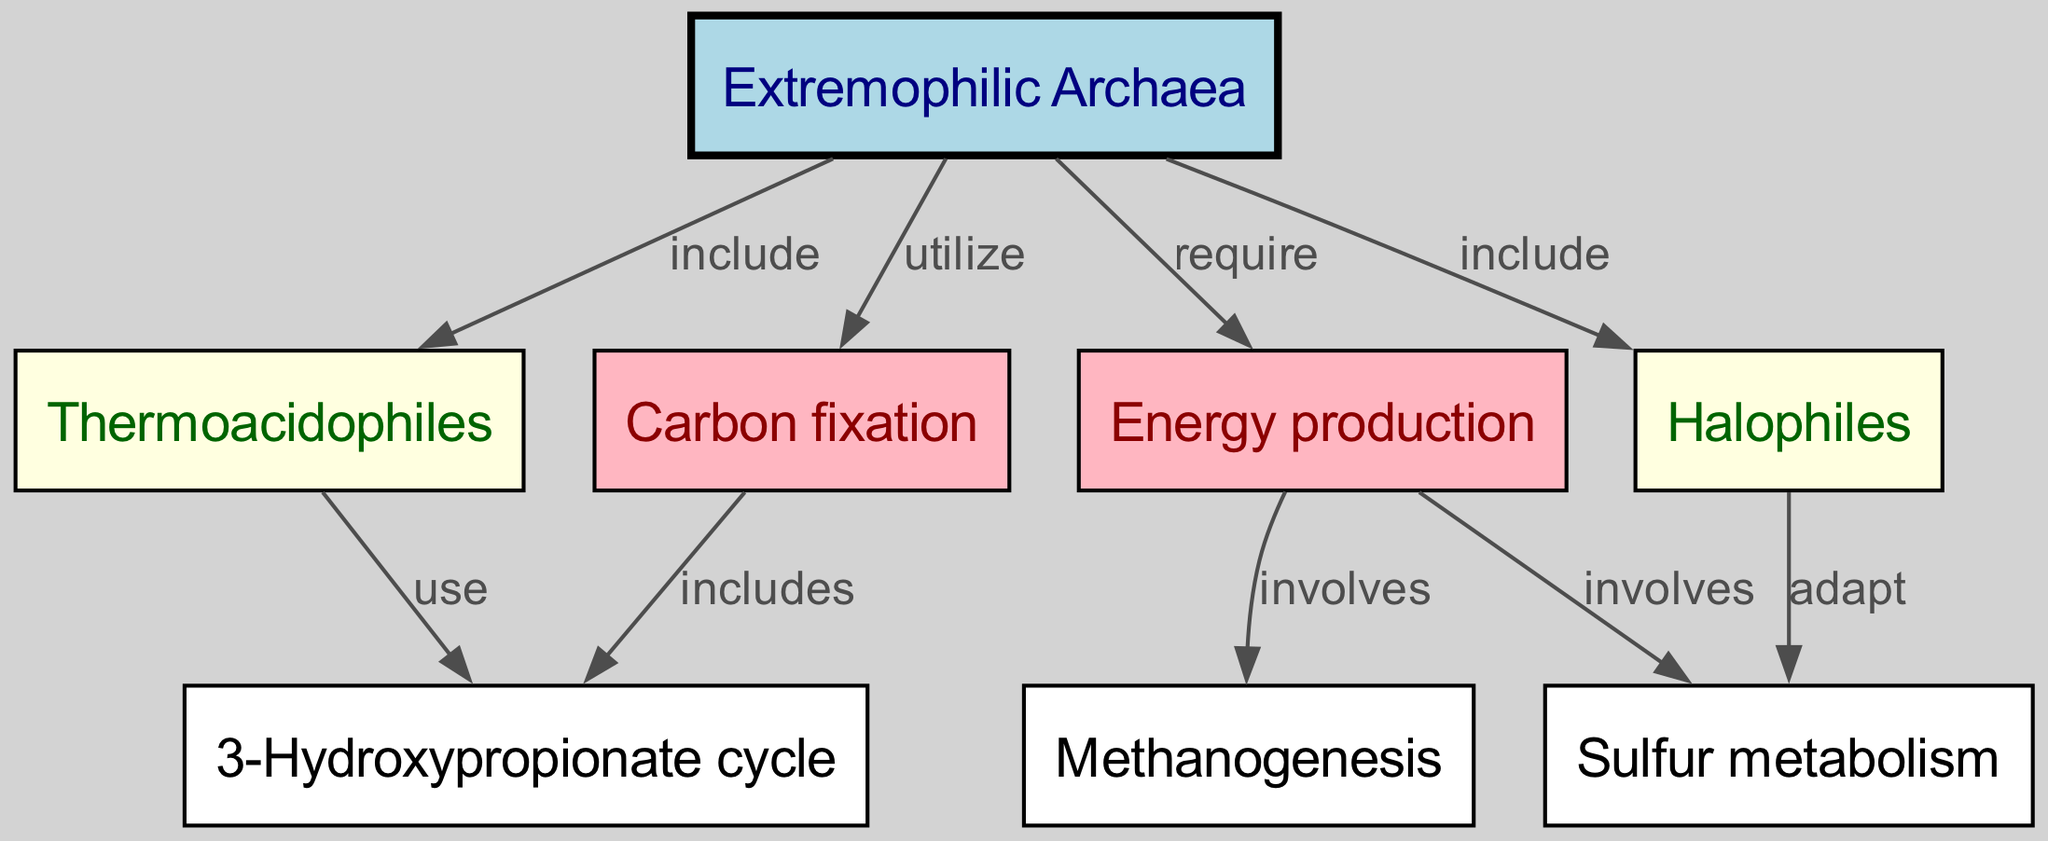What is the total number of nodes in the diagram? The diagram includes multiple nodes representing different metabolic pathways and types of Archaea. By counting each unique node in the provided data, we find there are 8 nodes.
Answer: 8 Which type of Archaea is involved in the 3-Hydroxypropionate cycle? The diagram shows that the 3-Hydroxypropionate cycle is included under carbon fixation, which is connected to the 'Thermoacidophiles' node. Therefore, 'Thermoacidophiles' are involved in this cycle.
Answer: Thermoacidophiles What metabolic process is utilized by extremophilic Archaea for energy production? The diagram indicates that 'Energy production' involves two processes: 'Methanogenesis' and 'Sulfur metabolism'. Thus, both are metabolic processes utilized for energy production.
Answer: Methanogenesis and Sulfur metabolism Which nodes are included under extremophilic Archaea? The diagram specifically lists 'Thermoacidophiles' and 'Halophiles' as types of extremophilic Archaea that are included under its main node.
Answer: Thermoacidophiles and Halophiles How does sulfur metabolism relate to extremophilic Archaea? The diagram shows a direct connection where 'Extremophilic Archaea' require 'Energy production', which involves sulfur metabolism. This shows that sulfur metabolism is a vital part of the energy production process for extremophilic Archaea.
Answer: Sulfur metabolism is involved in energy production What is the relationship between Halophiles and sulfur metabolism? The diagram demonstrates that Halophiles adapt to sulfur metabolism, showing a relationship where Halophiles are specifically suited for utilizing sulfur in their metabolic processes.
Answer: Adapt 